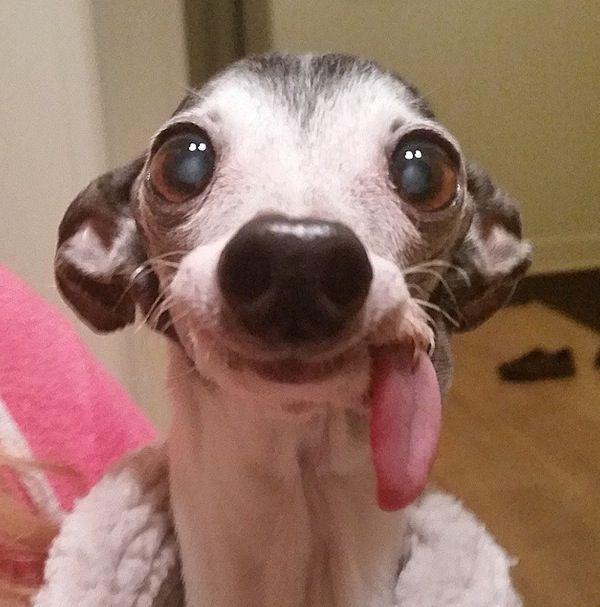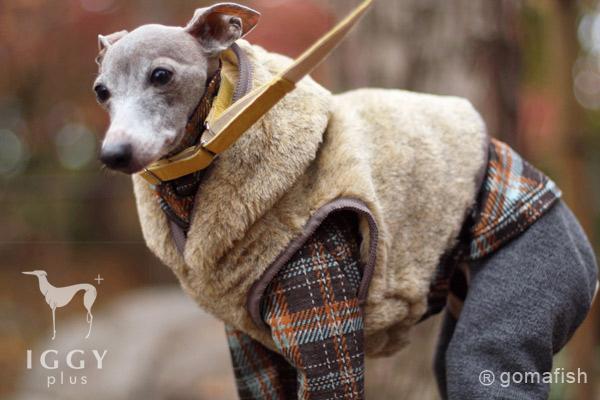The first image is the image on the left, the second image is the image on the right. Given the left and right images, does the statement "In one image, a dog's very long tongue is outside of its mouth and at least one ear is pulled towards the back of its head." hold true? Answer yes or no. Yes. The first image is the image on the left, the second image is the image on the right. For the images shown, is this caption "The dog in one of the images is sitting on a soft surface." true? Answer yes or no. No. 